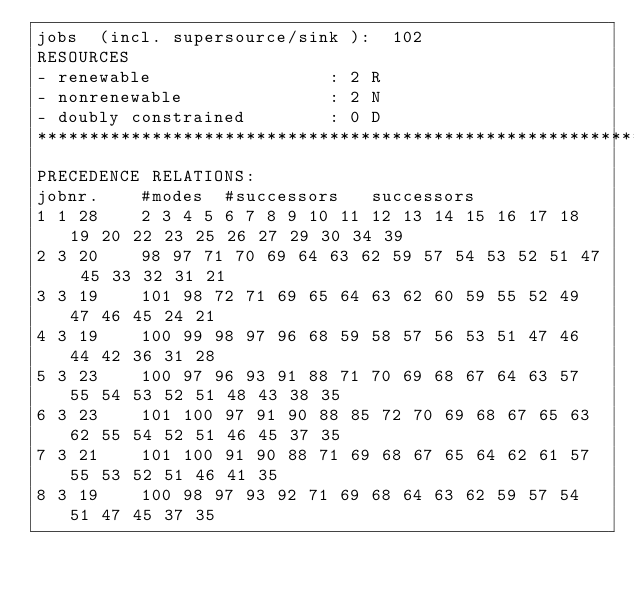<code> <loc_0><loc_0><loc_500><loc_500><_ObjectiveC_>jobs  (incl. supersource/sink ):	102
RESOURCES
- renewable                 : 2 R
- nonrenewable              : 2 N
- doubly constrained        : 0 D
************************************************************************
PRECEDENCE RELATIONS:
jobnr.    #modes  #successors   successors
1	1	28		2 3 4 5 6 7 8 9 10 11 12 13 14 15 16 17 18 19 20 22 23 25 26 27 29 30 34 39 
2	3	20		98 97 71 70 69 64 63 62 59 57 54 53 52 51 47 45 33 32 31 21 
3	3	19		101 98 72 71 69 65 64 63 62 60 59 55 52 49 47 46 45 24 21 
4	3	19		100 99 98 97 96 68 59 58 57 56 53 51 47 46 44 42 36 31 28 
5	3	23		100 97 96 93 91 88 71 70 69 68 67 64 63 57 55 54 53 52 51 48 43 38 35 
6	3	23		101 100 97 91 90 88 85 72 70 69 68 67 65 63 62 55 54 52 51 46 45 37 35 
7	3	21		101 100 91 90 88 71 69 68 67 65 64 62 61 57 55 53 52 51 46 41 35 
8	3	19		100 98 97 93 92 71 69 68 64 63 62 59 57 54 51 47 45 37 35 </code> 